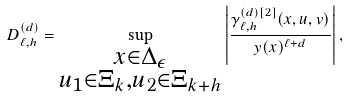<formula> <loc_0><loc_0><loc_500><loc_500>D _ { \ell , h } ^ { ( d ) } = \sup _ { \substack { x \in \Delta _ { \epsilon } \\ u _ { 1 } \in \Xi _ { k } , u _ { 2 } \in \Xi _ { k + h } } } \left | \frac { \gamma _ { \ell , h } ^ { ( d ) [ 2 ] } ( x , u , v ) } { y ( x ) ^ { \ell + d } } \right | ,</formula> 